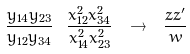Convert formula to latex. <formula><loc_0><loc_0><loc_500><loc_500>\frac { y _ { 1 4 } y _ { 2 3 } } { y _ { 1 2 } y _ { 3 4 } } \ \frac { x ^ { 2 } _ { 1 2 } x ^ { 2 } _ { 3 4 } } { x ^ { 2 } _ { 1 4 } x ^ { 2 } _ { 2 3 } } \ \rightarrow \ \frac { z z ^ { \prime } } { w }</formula> 